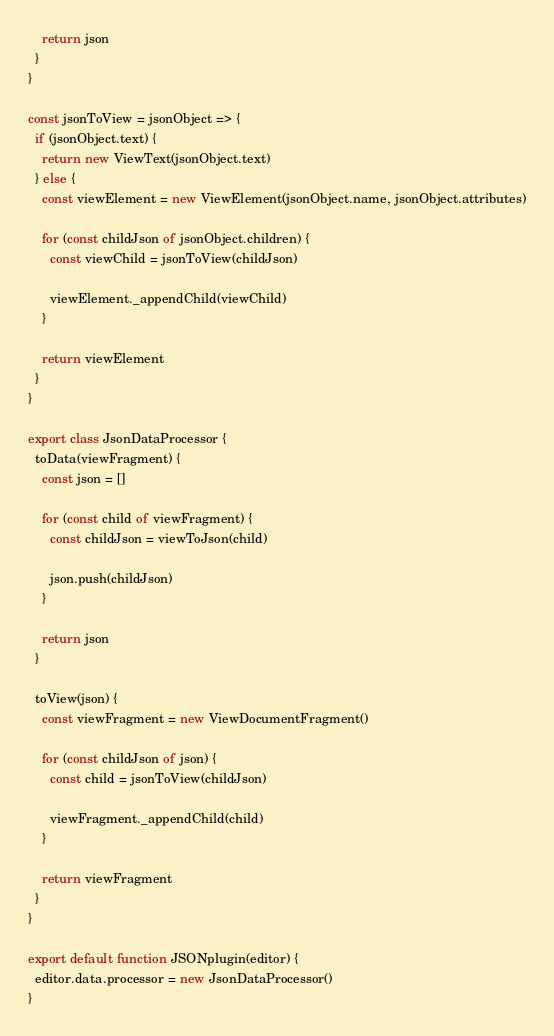<code> <loc_0><loc_0><loc_500><loc_500><_JavaScript_>
    return json
  }
}

const jsonToView = jsonObject => {
  if (jsonObject.text) {
    return new ViewText(jsonObject.text)
  } else {
    const viewElement = new ViewElement(jsonObject.name, jsonObject.attributes)

    for (const childJson of jsonObject.children) {
      const viewChild = jsonToView(childJson)

      viewElement._appendChild(viewChild)
    }

    return viewElement
  }
}

export class JsonDataProcessor {
  toData(viewFragment) {
    const json = []

    for (const child of viewFragment) {
      const childJson = viewToJson(child)

      json.push(childJson)
    }

    return json
  }

  toView(json) {
    const viewFragment = new ViewDocumentFragment()

    for (const childJson of json) {
      const child = jsonToView(childJson)

      viewFragment._appendChild(child)
    }

    return viewFragment
  }
}

export default function JSONplugin(editor) {
  editor.data.processor = new JsonDataProcessor()
}
</code> 